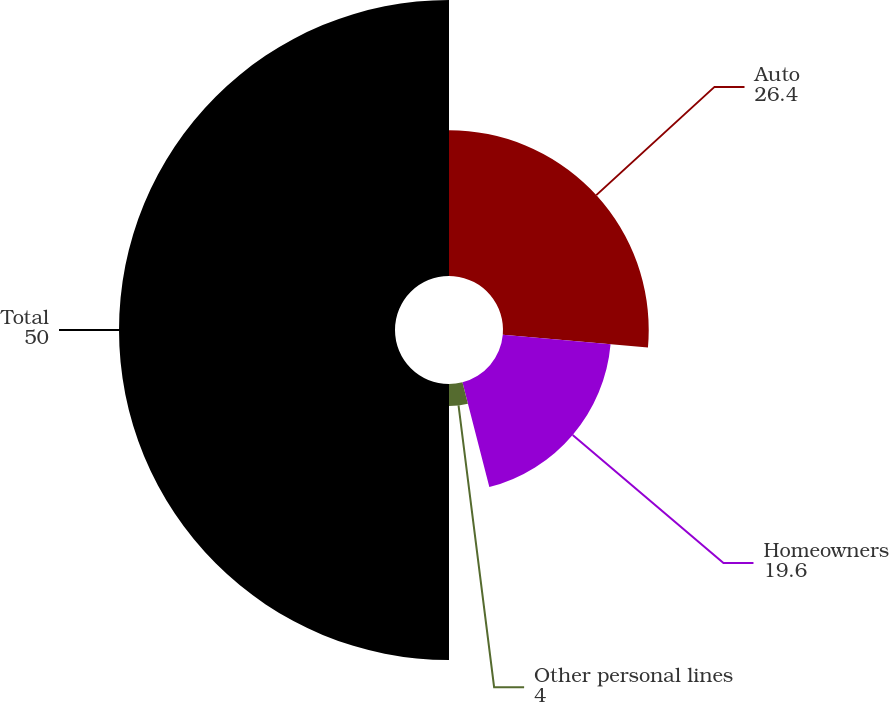Convert chart. <chart><loc_0><loc_0><loc_500><loc_500><pie_chart><fcel>Auto<fcel>Homeowners<fcel>Other personal lines<fcel>Total<nl><fcel>26.4%<fcel>19.6%<fcel>4.0%<fcel>50.0%<nl></chart> 